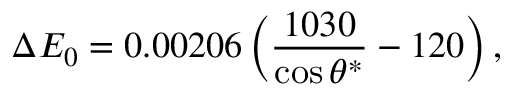<formula> <loc_0><loc_0><loc_500><loc_500>\Delta E _ { 0 } = 0 . 0 0 2 0 6 \left ( \frac { 1 0 3 0 } { \cos \theta ^ { * } } - 1 2 0 \right ) ,</formula> 